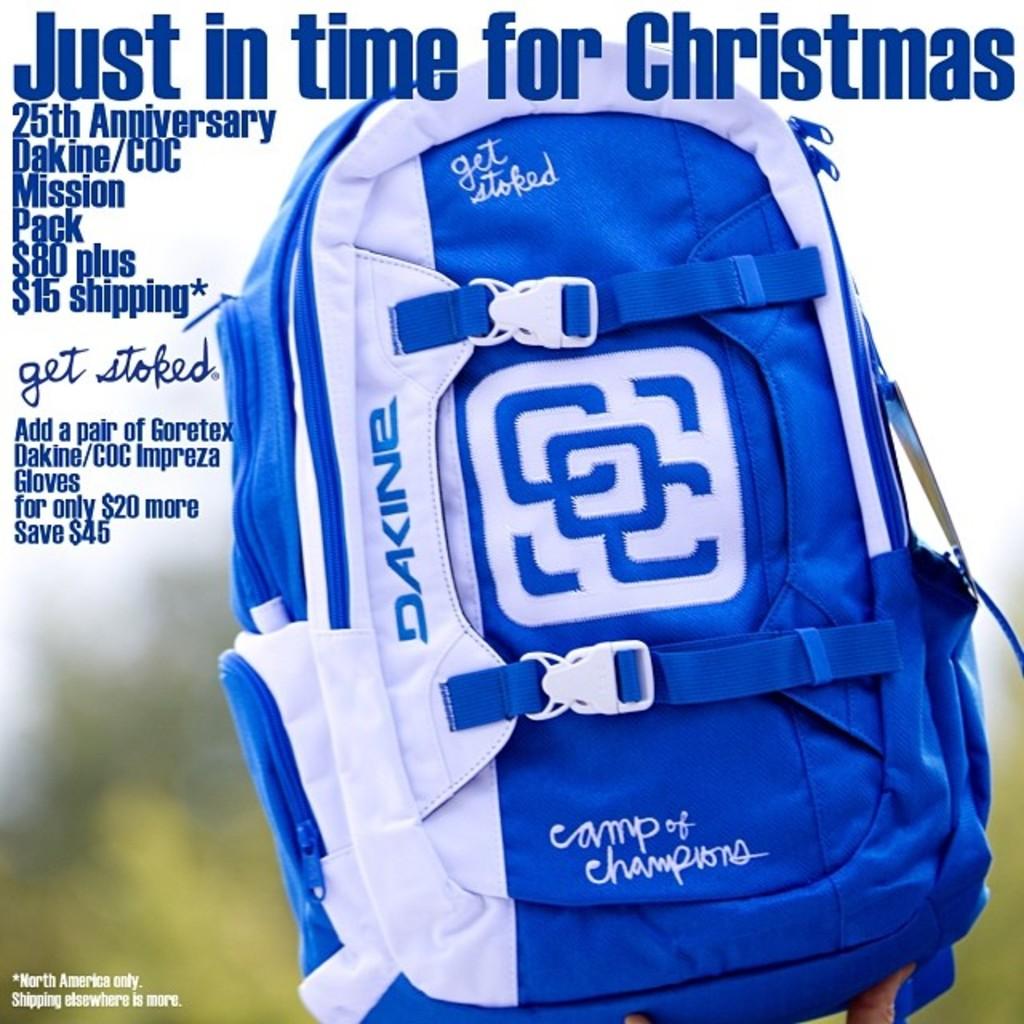What is this backpack in time for?
Keep it short and to the point. Christmas. What holiday is mentioned?
Your answer should be compact. Christmas. 